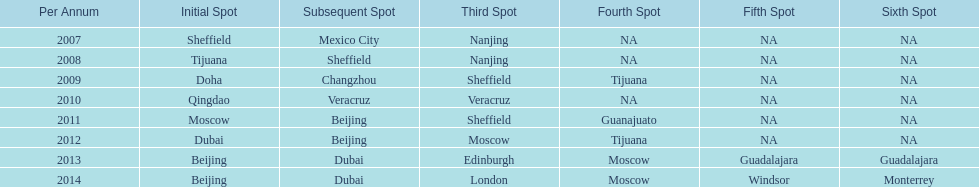What years had the most venues? 2013, 2014. 